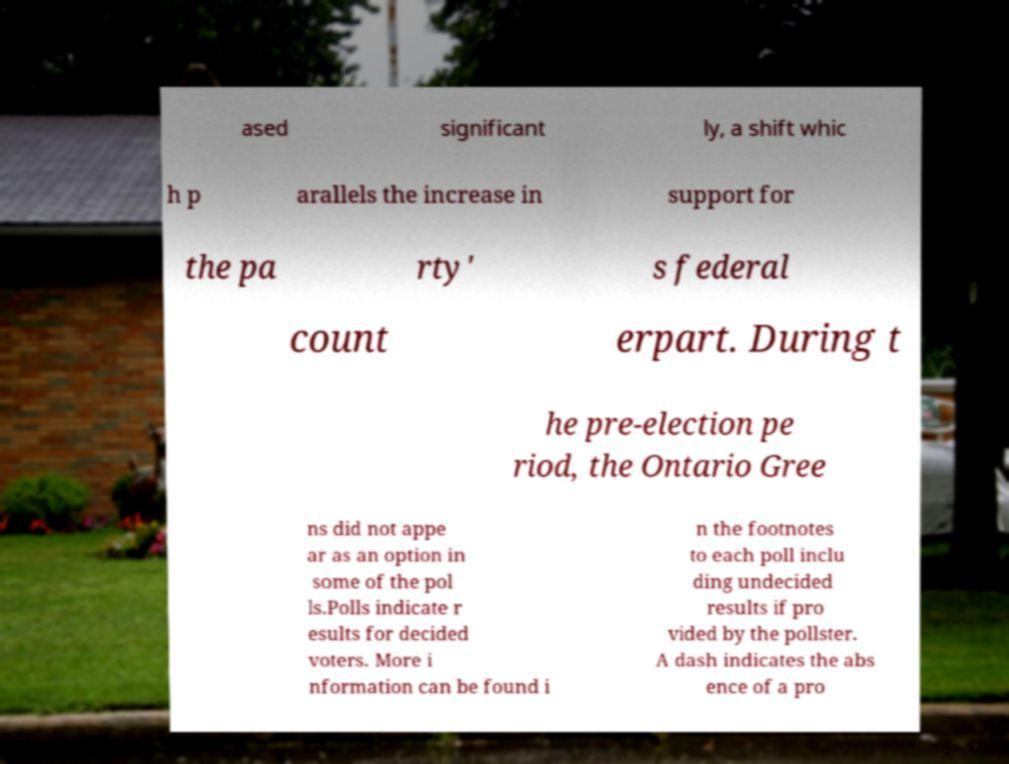Can you accurately transcribe the text from the provided image for me? ased significant ly, a shift whic h p arallels the increase in support for the pa rty' s federal count erpart. During t he pre-election pe riod, the Ontario Gree ns did not appe ar as an option in some of the pol ls.Polls indicate r esults for decided voters. More i nformation can be found i n the footnotes to each poll inclu ding undecided results if pro vided by the pollster. A dash indicates the abs ence of a pro 